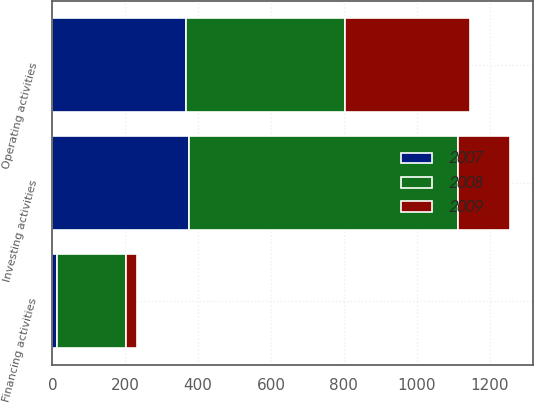<chart> <loc_0><loc_0><loc_500><loc_500><stacked_bar_chart><ecel><fcel>Operating activities<fcel>Investing activities<fcel>Financing activities<nl><fcel>2007<fcel>367.5<fcel>374.2<fcel>13.6<nl><fcel>2008<fcel>434.4<fcel>739.3<fcel>187.9<nl><fcel>2009<fcel>343.8<fcel>142.4<fcel>29.5<nl></chart> 